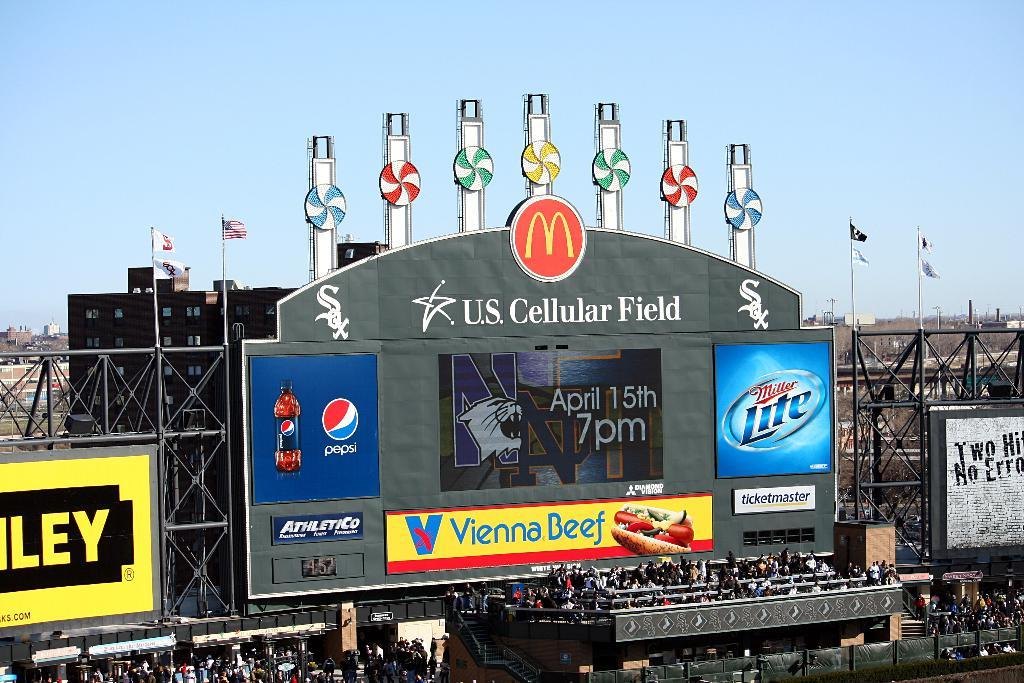<image>
Relay a brief, clear account of the picture shown. A large outdoor stadium display board with U.S. Cellular Field on it. 